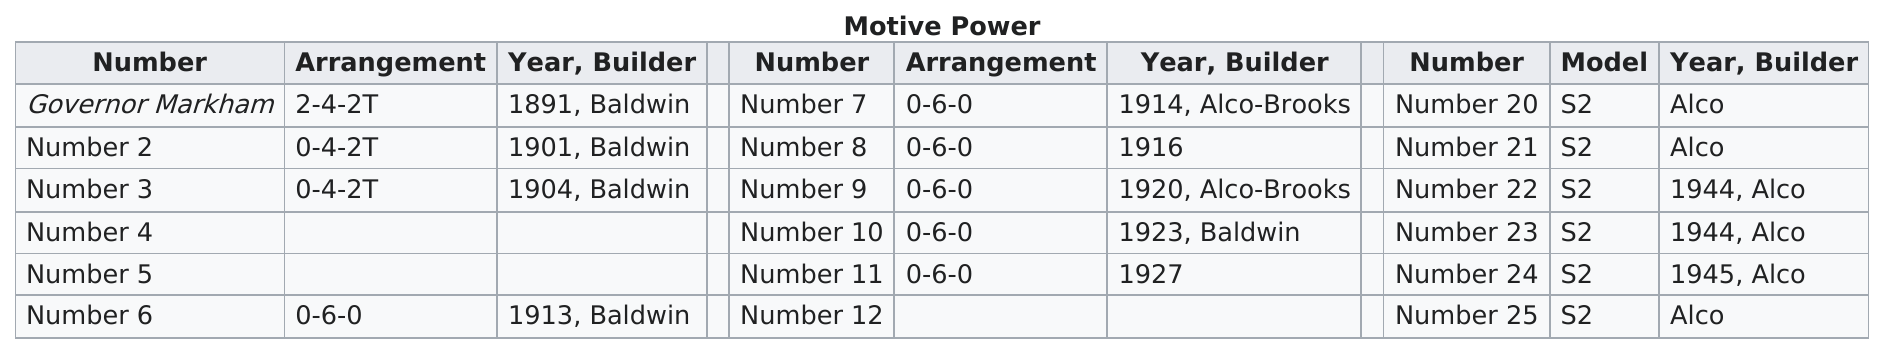Indicate a few pertinent items in this graphic. There are 10 trains on the graph that do not mention "alco" or "alco-brooks" as their builder. It is estimated that there are six trains in the world with a 0-6-0 wheel arrangement. 